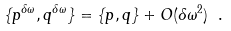Convert formula to latex. <formula><loc_0><loc_0><loc_500><loc_500>\{ p ^ { \delta \omega } , q ^ { \delta \omega } \} = \{ p , q \} + O ( \delta \omega ^ { 2 } ) \ .</formula> 